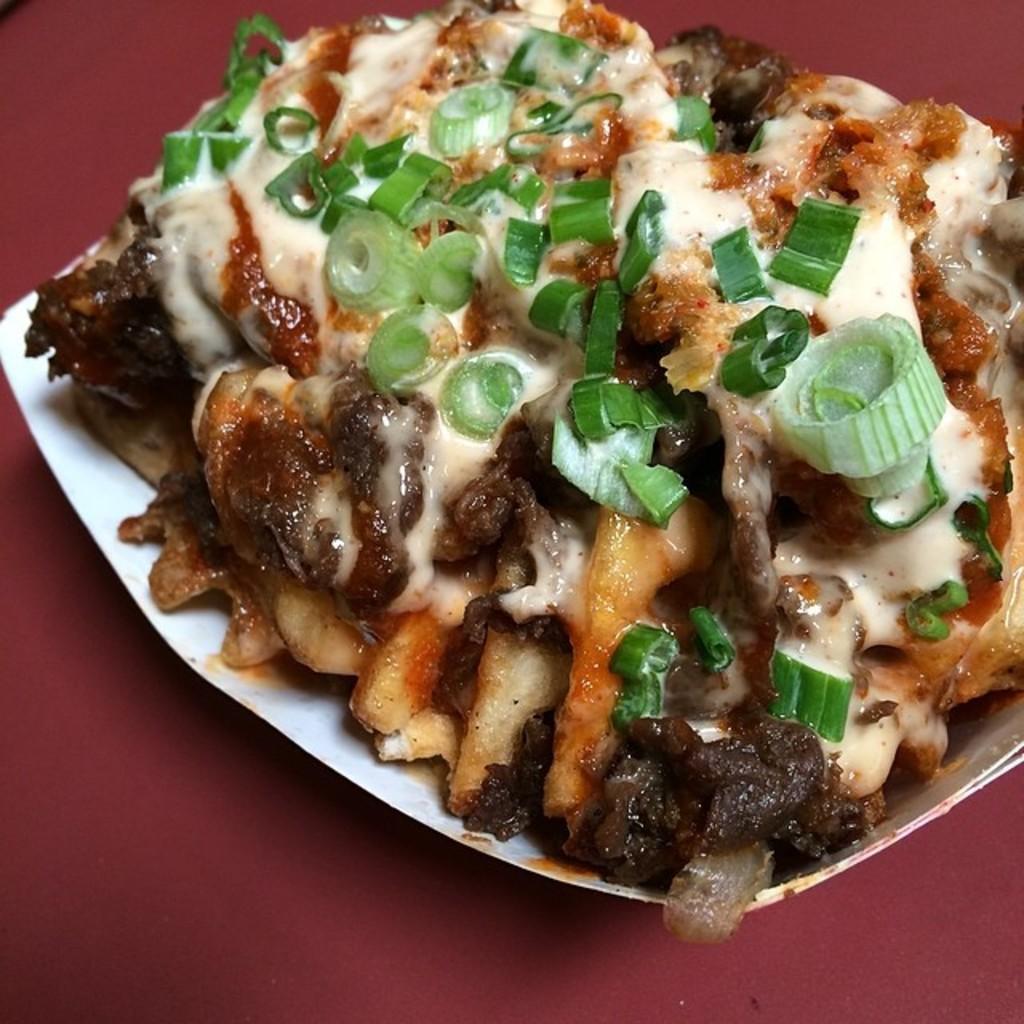Describe this image in one or two sentences. In this picture we can see food in the plate. 